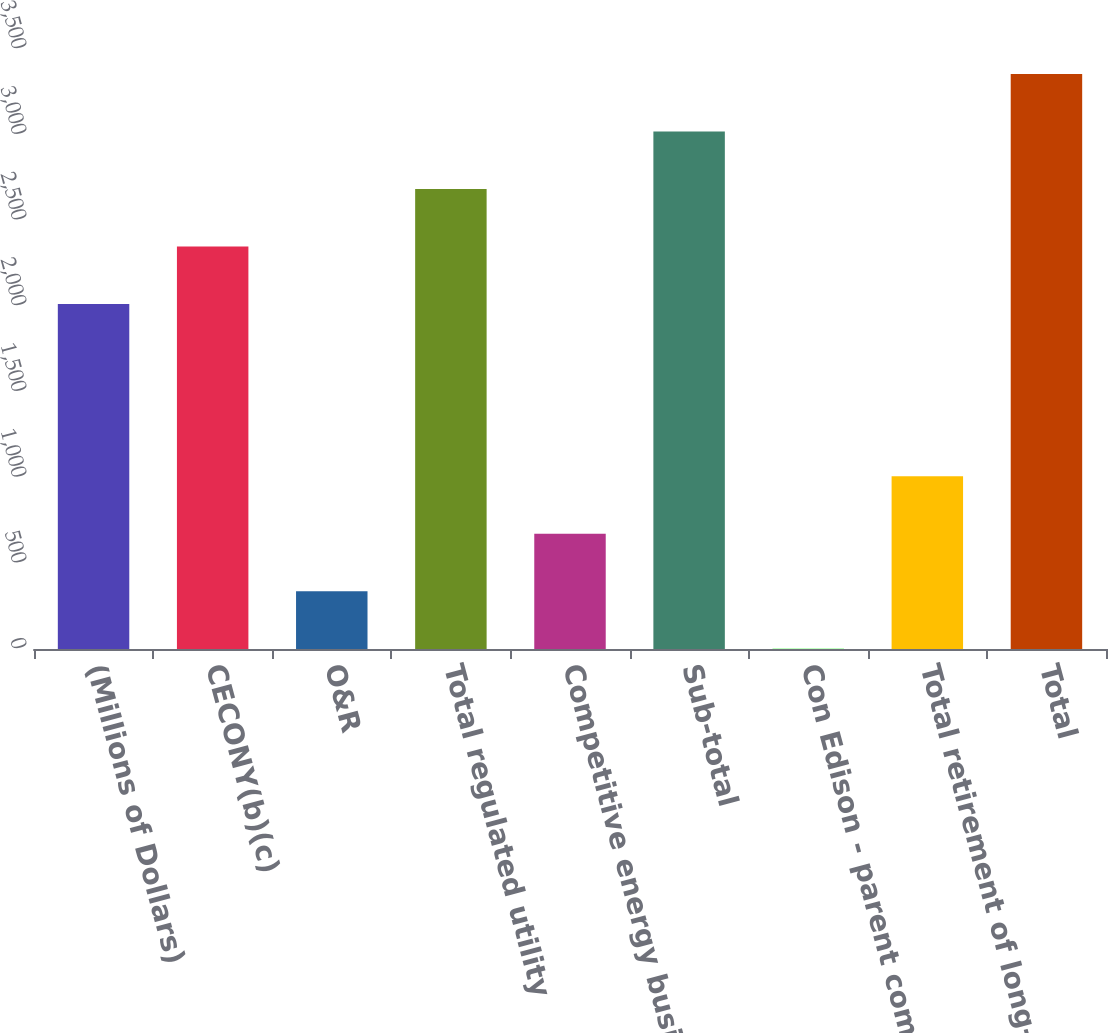<chart> <loc_0><loc_0><loc_500><loc_500><bar_chart><fcel>(Millions of Dollars)<fcel>CECONY(b)(c)<fcel>O&R<fcel>Total regulated utility<fcel>Competitive energy businesses<fcel>Sub-total<fcel>Con Edison - parent company<fcel>Total retirement of long-term<fcel>Total<nl><fcel>2013<fcel>2348.2<fcel>337.2<fcel>2683.4<fcel>672.4<fcel>3018.6<fcel>2<fcel>1007.6<fcel>3354<nl></chart> 